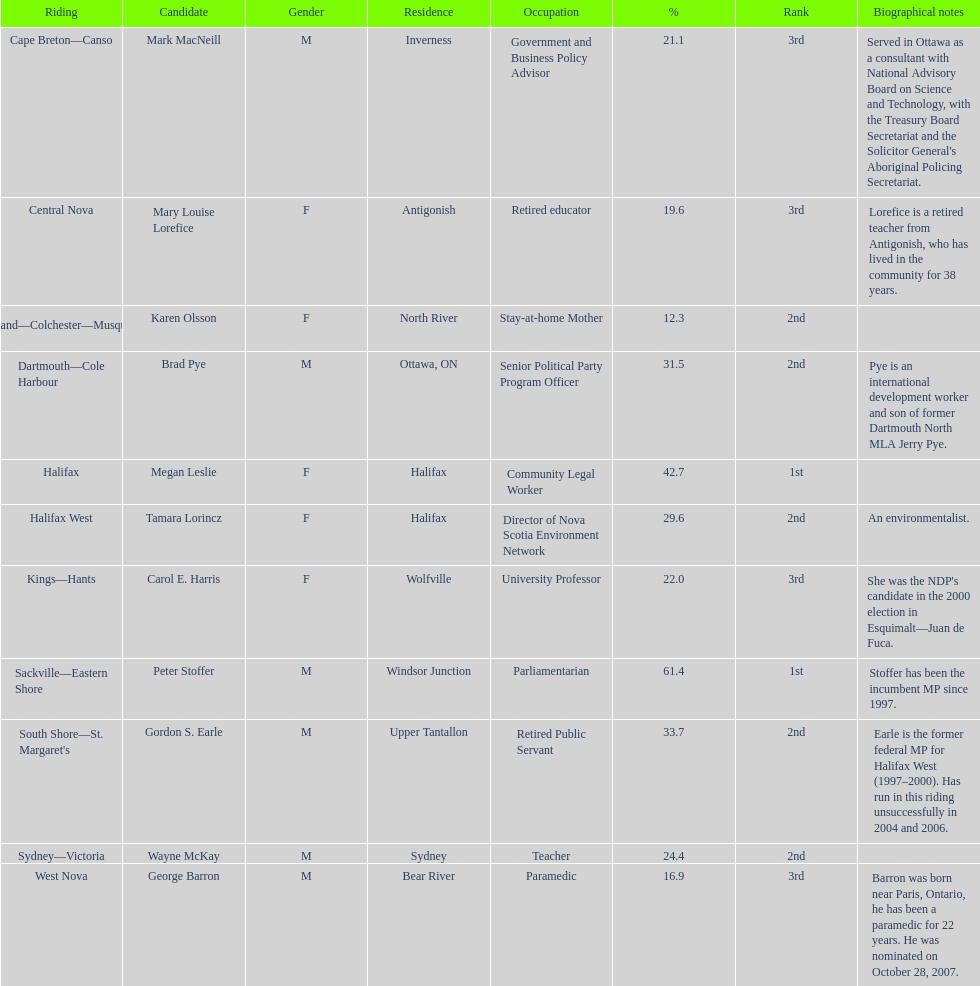How many applicants were from halifax? 2. 